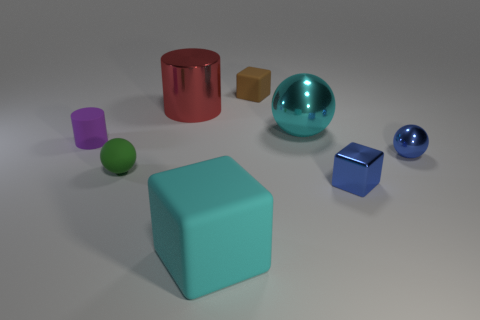Is there anything else that has the same size as the metal cylinder?
Make the answer very short. Yes. Is the color of the metallic cube the same as the tiny shiny ball?
Provide a succinct answer. Yes. Is the material of the small purple cylinder the same as the cyan thing that is on the left side of the small brown rubber object?
Give a very brief answer. Yes. Is there any other thing that has the same color as the big matte thing?
Provide a short and direct response. Yes. How many things are rubber things to the right of the tiny purple cylinder or cyan objects that are behind the tiny green object?
Provide a short and direct response. 4. There is a matte object that is both on the left side of the red metal object and to the right of the purple rubber cylinder; what shape is it?
Make the answer very short. Sphere. There is a ball that is to the right of the big cyan metal ball; how many balls are left of it?
Provide a short and direct response. 2. What number of things are small blocks behind the metal cube or tiny blue shiny objects?
Keep it short and to the point. 3. How big is the matte cube in front of the metal cylinder?
Your answer should be compact. Large. What is the material of the cyan ball?
Offer a terse response. Metal. 